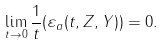Convert formula to latex. <formula><loc_0><loc_0><loc_500><loc_500>\lim _ { t \to 0 } \frac { 1 } { t } ( \varepsilon _ { a } ( t , Z , Y ) ) = 0 .</formula> 